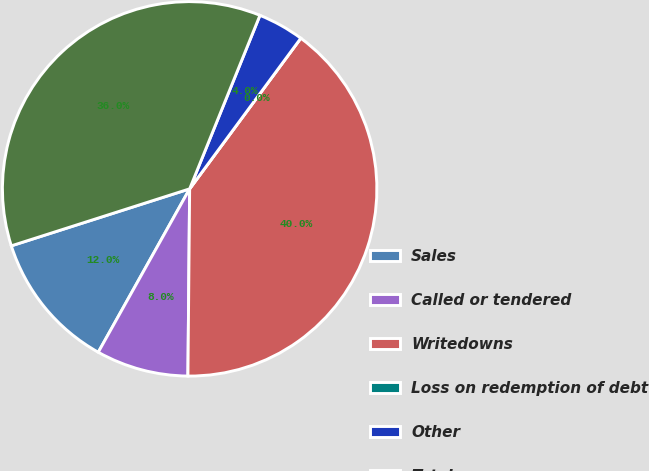Convert chart. <chart><loc_0><loc_0><loc_500><loc_500><pie_chart><fcel>Sales<fcel>Called or tendered<fcel>Writedowns<fcel>Loss on redemption of debt<fcel>Other<fcel>Total<nl><fcel>11.96%<fcel>7.97%<fcel>40.03%<fcel>0.0%<fcel>3.99%<fcel>36.05%<nl></chart> 